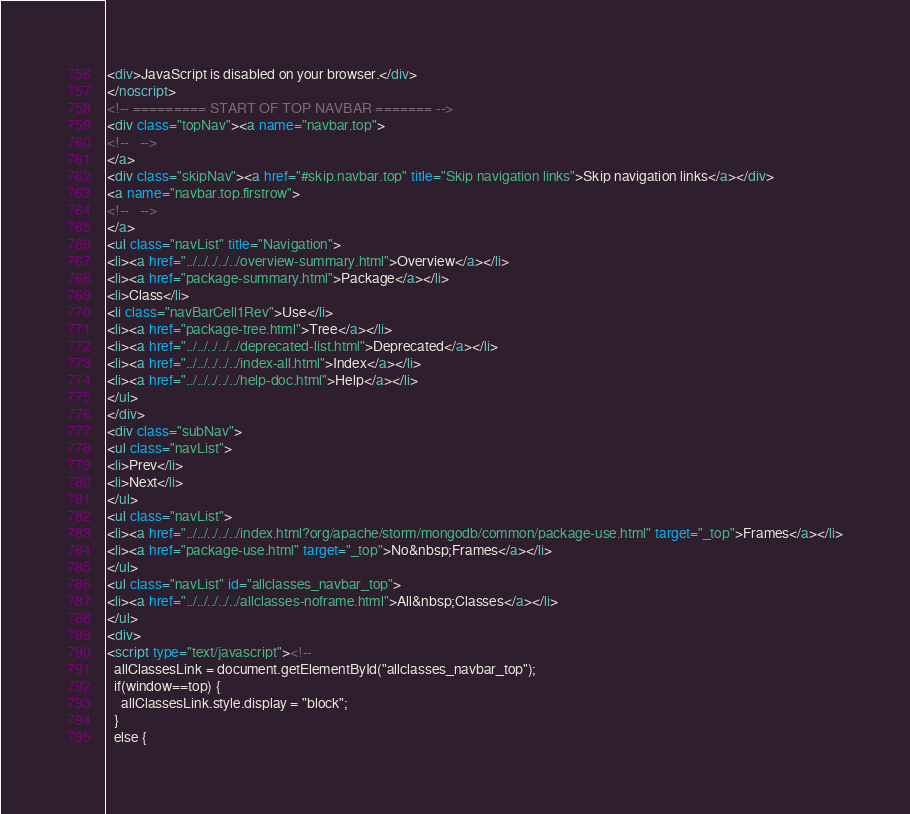<code> <loc_0><loc_0><loc_500><loc_500><_HTML_><div>JavaScript is disabled on your browser.</div>
</noscript>
<!-- ========= START OF TOP NAVBAR ======= -->
<div class="topNav"><a name="navbar.top">
<!--   -->
</a>
<div class="skipNav"><a href="#skip.navbar.top" title="Skip navigation links">Skip navigation links</a></div>
<a name="navbar.top.firstrow">
<!--   -->
</a>
<ul class="navList" title="Navigation">
<li><a href="../../../../../overview-summary.html">Overview</a></li>
<li><a href="package-summary.html">Package</a></li>
<li>Class</li>
<li class="navBarCell1Rev">Use</li>
<li><a href="package-tree.html">Tree</a></li>
<li><a href="../../../../../deprecated-list.html">Deprecated</a></li>
<li><a href="../../../../../index-all.html">Index</a></li>
<li><a href="../../../../../help-doc.html">Help</a></li>
</ul>
</div>
<div class="subNav">
<ul class="navList">
<li>Prev</li>
<li>Next</li>
</ul>
<ul class="navList">
<li><a href="../../../../../index.html?org/apache/storm/mongodb/common/package-use.html" target="_top">Frames</a></li>
<li><a href="package-use.html" target="_top">No&nbsp;Frames</a></li>
</ul>
<ul class="navList" id="allclasses_navbar_top">
<li><a href="../../../../../allclasses-noframe.html">All&nbsp;Classes</a></li>
</ul>
<div>
<script type="text/javascript"><!--
  allClassesLink = document.getElementById("allclasses_navbar_top");
  if(window==top) {
    allClassesLink.style.display = "block";
  }
  else {</code> 